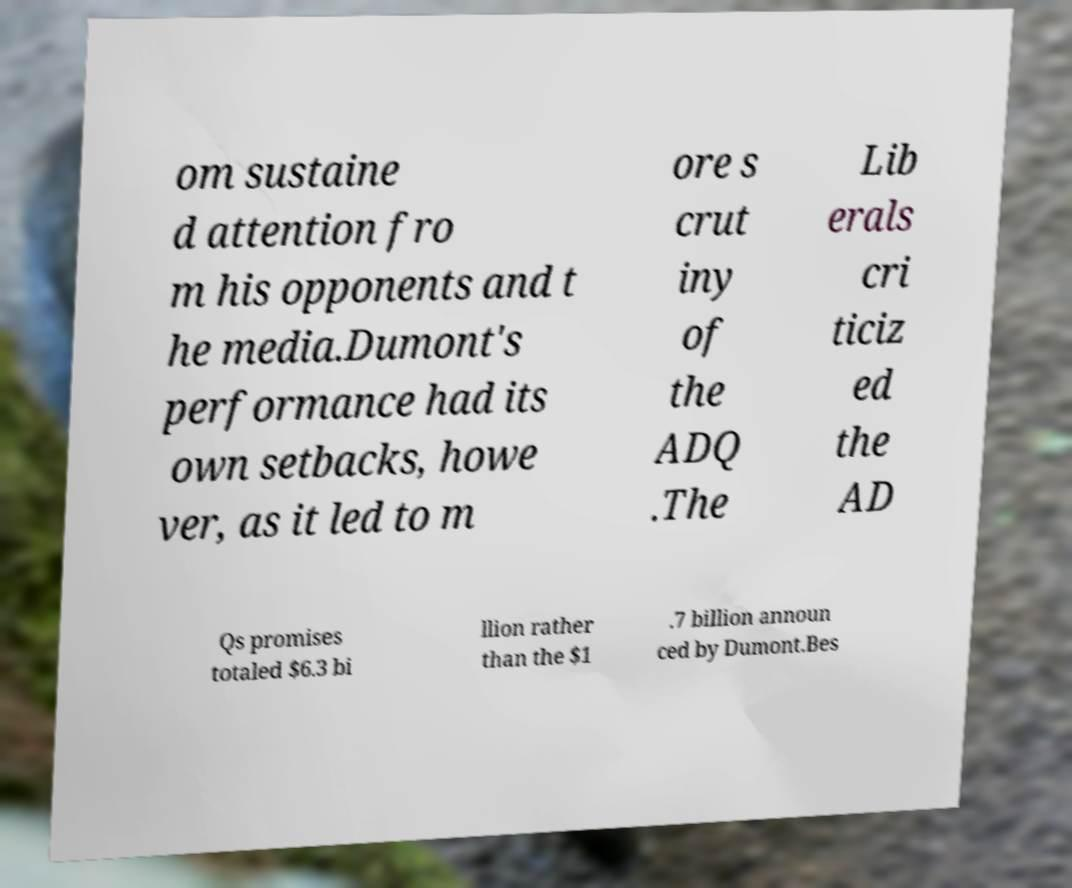Please identify and transcribe the text found in this image. om sustaine d attention fro m his opponents and t he media.Dumont's performance had its own setbacks, howe ver, as it led to m ore s crut iny of the ADQ .The Lib erals cri ticiz ed the AD Qs promises totaled $6.3 bi llion rather than the $1 .7 billion announ ced by Dumont.Bes 